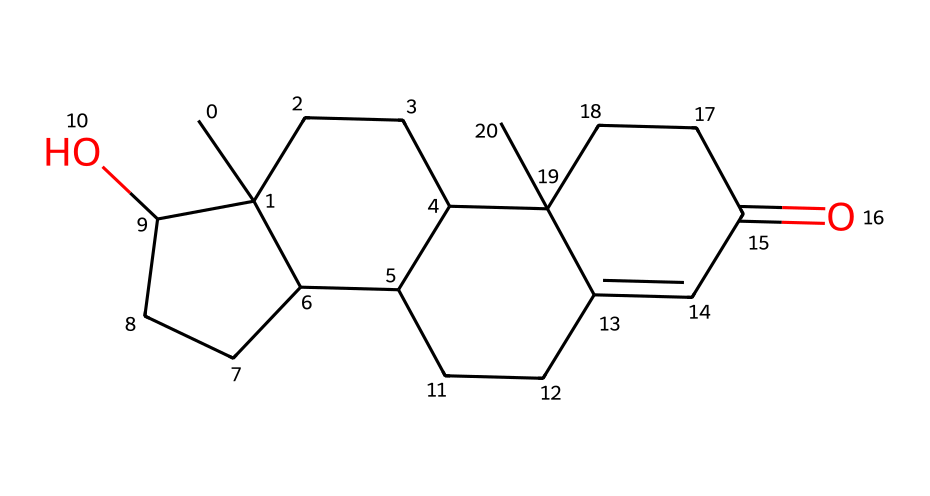What is the molecular formula of testosterone based on the SMILES representation? By analyzing the SMILES string, we can identify the types and counts of atoms present. Carbon (C) appears frequently, and by counting the occurrences, we find there are 19 carbon atoms, along with 28 hydrogen and 2 oxygen atoms. Thus, the molecular formula is C19H28O2.
Answer: C19H28O2 How many rings are present in the structure of testosterone? The SMILES representation shows multiple cycles in its structure. By interpreting it, we can identify four distinct rings interlinked, indicating a tetracyclic structure.
Answer: 4 What role does testosterone play in muscle growth? Testosterone is a hormone that promotes protein synthesis, muscle repair, and growth, thus facilitating muscle hypertrophy and performance enhancement.
Answer: muscle growth Which atom in testosterone is responsible for its biological function as a hormone? The presence of the hydroxyl group (-OH) at C1 in the structure allows testosterone to bind to androgen receptors, enabling its hormonal function.
Answer: hydroxyl group What type of chemical is testosterone classified as? Testosterone is classified as a steroid hormone due to its tetracyclic structure consisting of four fused rings, characteristic of steroids.
Answer: steroid hormone What is the significance of the double bond in the chemical structure of testosterone? The double bond in the structure contributes to the stability and reactivity of testosterone, affecting its interactions with androgen receptors and influencing its biological effects.
Answer: stability and reactivity 